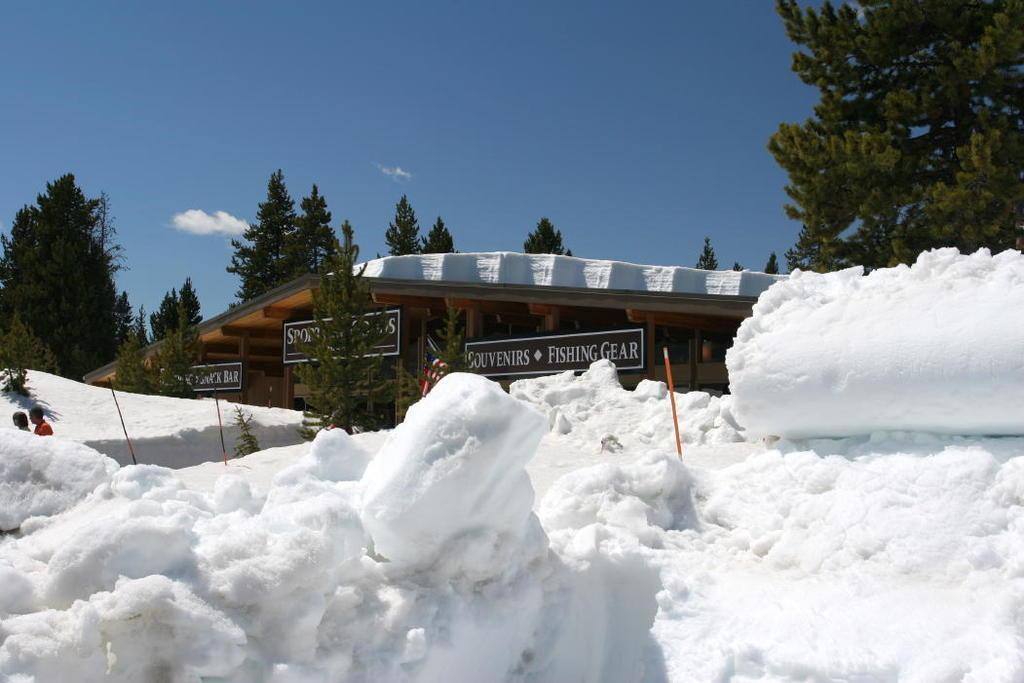How would you summarize this image in a sentence or two? In the foreground of this image, there is the snow and the few poles on it. In the background, there are trees, a shelter, sky and the cloud. 